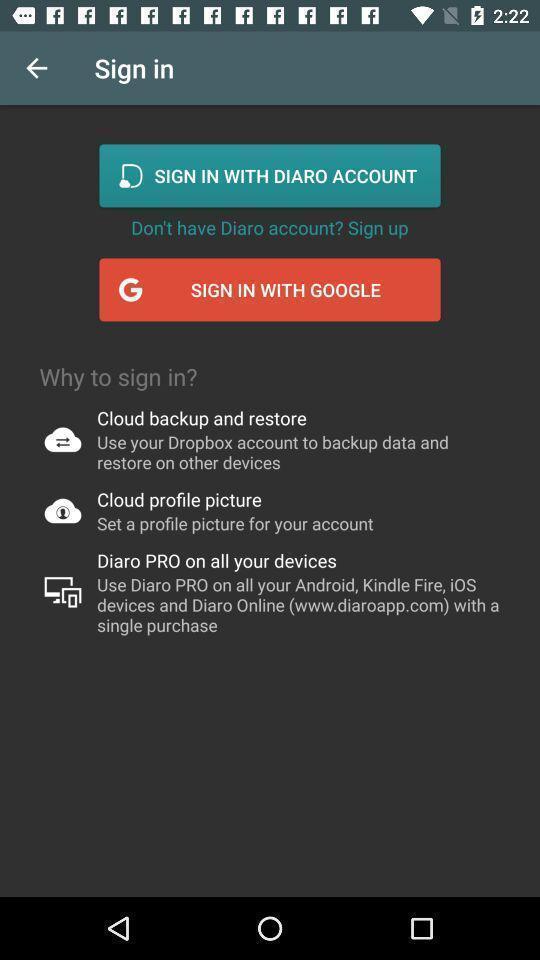Provide a detailed account of this screenshot. Sign in page to get the access from application. 